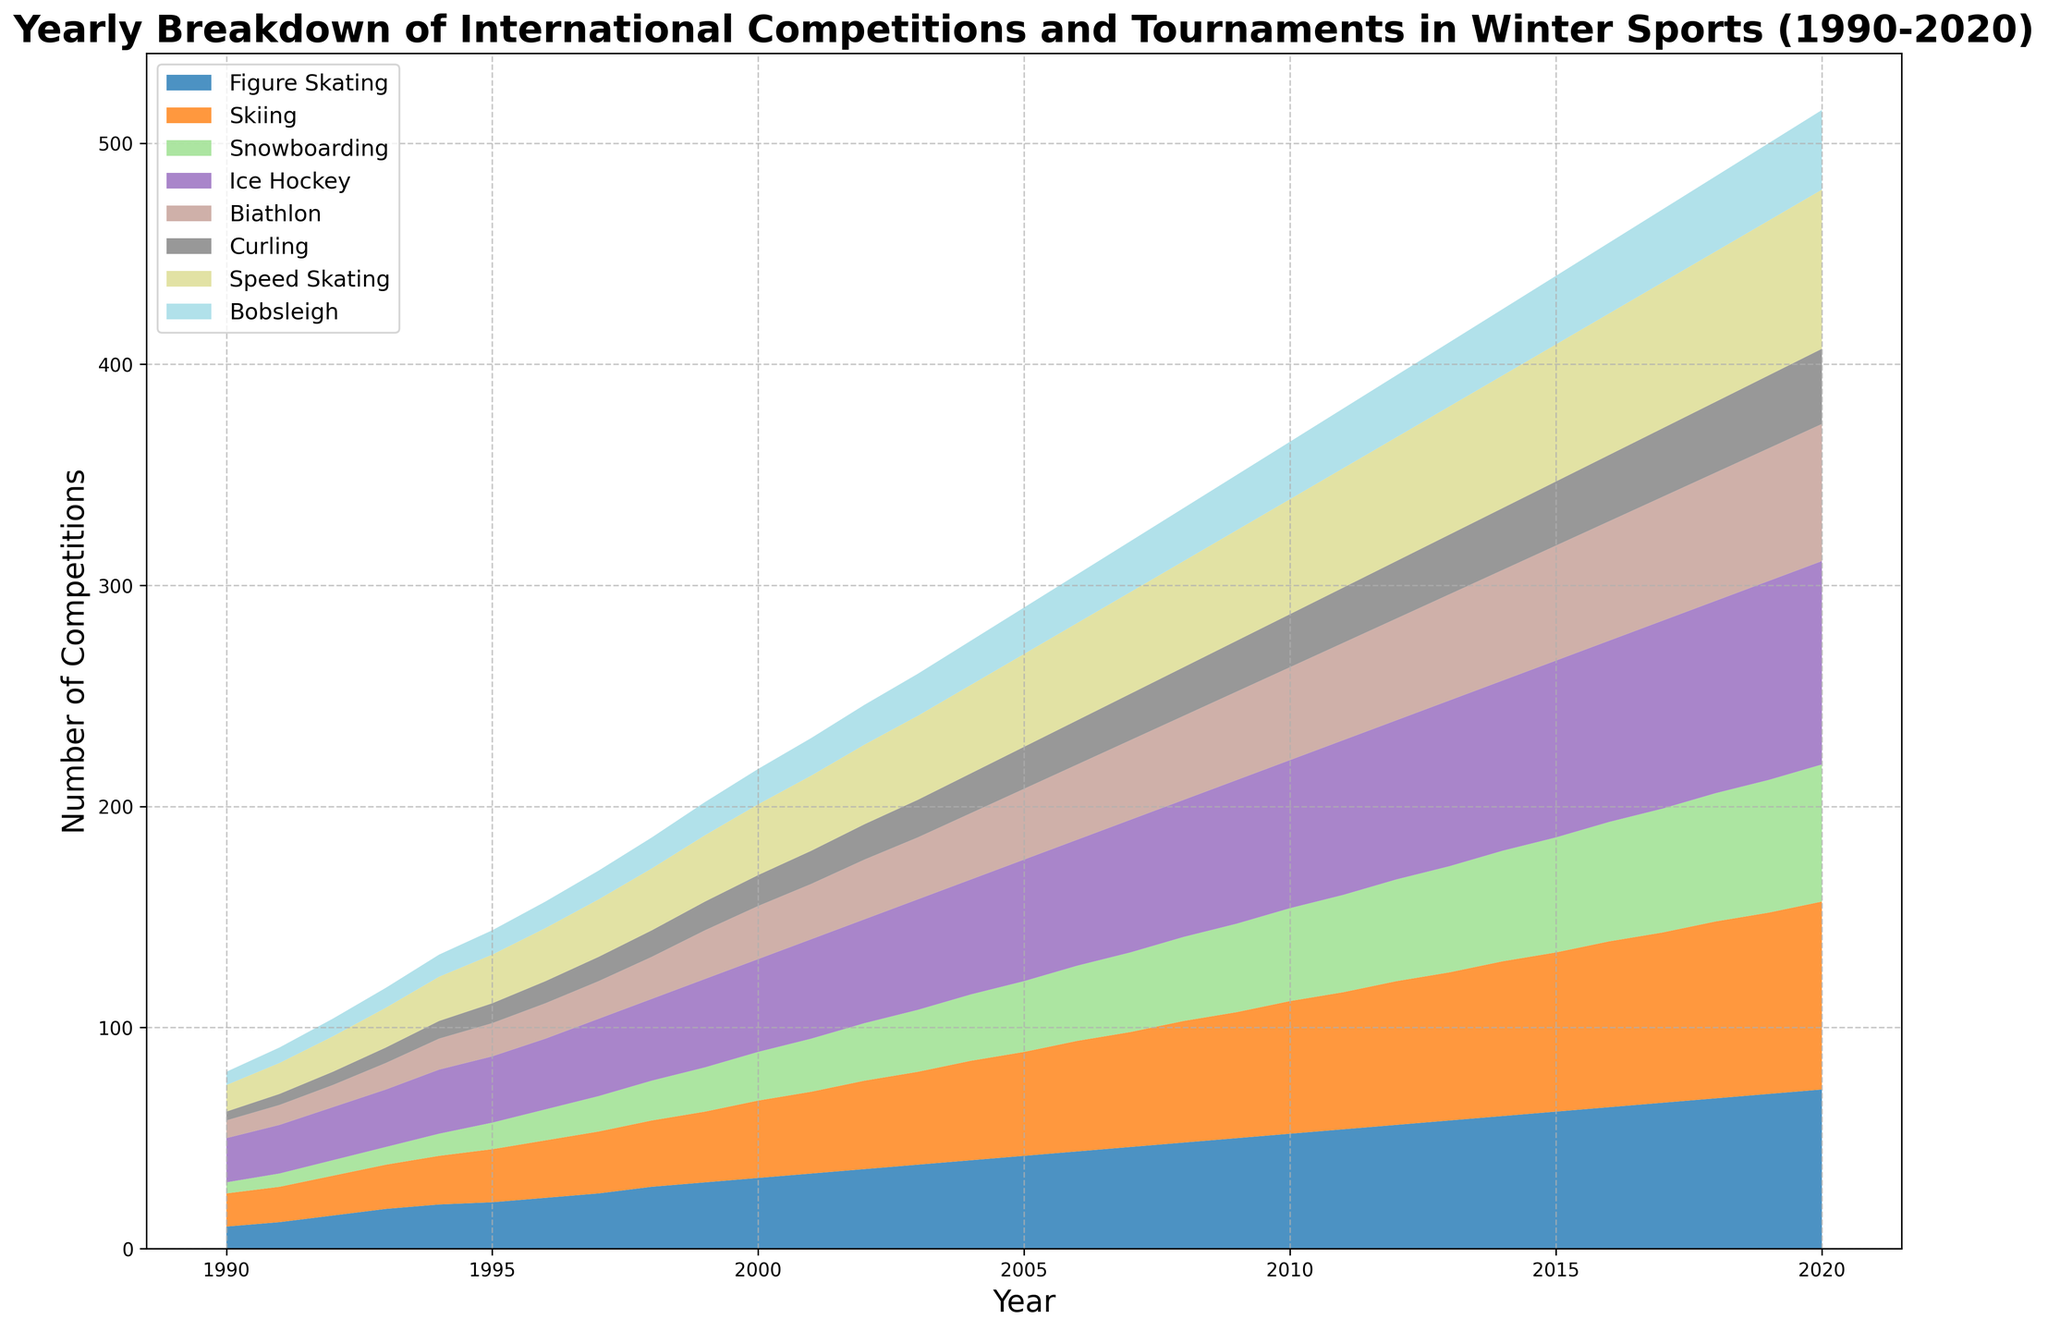What years show a noticeable increase in the number of Figure Skating competitions? By looking at the chart, we can see when the area representing Figure Skating starts to rise more rapidly. The increments from 1997 onwards appear steep. Therefore, the years with a noticeable increase are post-1997.
Answer: Post-1997 How do the number of Ice Hockey competitions in 2000 compare with those in 2020? By observing the heights of the respective segments for Ice Hockey in 2000 and 2020. The number of competitions is higher in 2020 compared to 2000, visually confirmed by the larger area above the year 2020.
Answer: Higher in 2020 Which sport had the most competitions in 1995? By examining the heights of the areas in the stack plot for 1995, Ice Hockey is seen having the tallest area. Therefore, Ice Hockey had the most competitions in 1995.
Answer: Ice Hockey What is the sum of Curling and Speed Skating competitions in 2010? From the chart, the numbers of competitions for Curling and Speed Skating in 2010 are 24 and 52, respectively. Summing these two values gives 24 + 52 = 76.
Answer: 76 Which sport appears to grow the most steadily over the years? Observing the chart, Figure Skating shows a consistent and steady increase from 1990 to 2020, with no abrupt changes in the growth pattern.
Answer: Figure Skating Was Biathlon always less popular than Bobsleigh between 1990 and 2020? By comparing the areas of Biathlon and Bobsleigh over each year. Biathlon starts with fewer competitions but surpasses Bobsleigh around the mid-period and remains higher.
Answer: Not always What is the largest approximate increase in the number of Snowboarding competitions between two consecutive years? Checking the chart for sharp rises in the Snowboarding area, the largest jump appears between 2019 and 2020, going from 60 to 62, an increase of approximately 2.
Answer: 2 How does the color of the area for Skiing differ from the area for Curling? Skiing is represented by one of the dominant colors that is brighter and more prominent, while Curling has a distinct, less dominant color. The exact hues can vary, but visually they are quite different.
Answer: Distinct different colors What is the combined number of competitions for all sports in 2002? Summing the values for all sports in the year 2002: 36 (FS) + 40 (SK) + 26 (SB) + 47 (IH) + 27 (B) + 16 (C) + 36 (SS) + 18 (BS) = 246
Answer: 246 Compare the growth trend of Speed Skating to that of Snowboarding. By looking at the areas for Speed Skating and Snowboarding over the years, both show growth, but Speed Skating has a more consistent increase, whereas Snowboarding shows more variability in its rate of increase.
Answer: Speed Skating is more consistent 